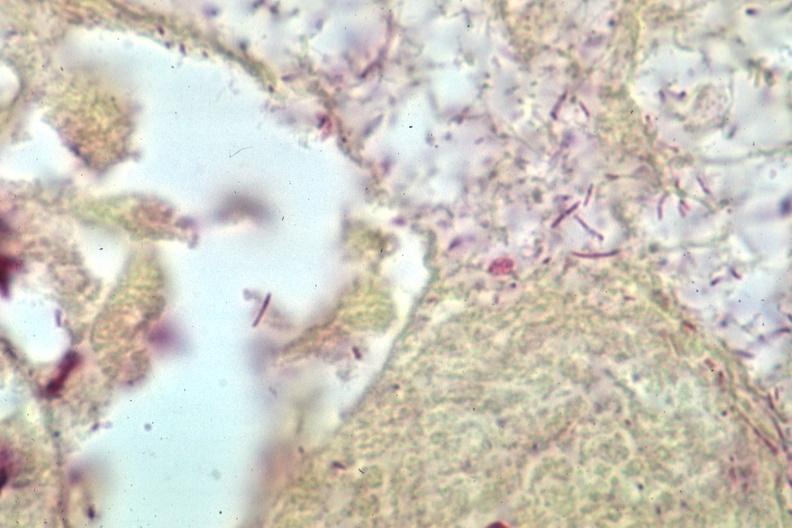how do grams stain gram bacteria?
Answer the question using a single word or phrase. Negative 